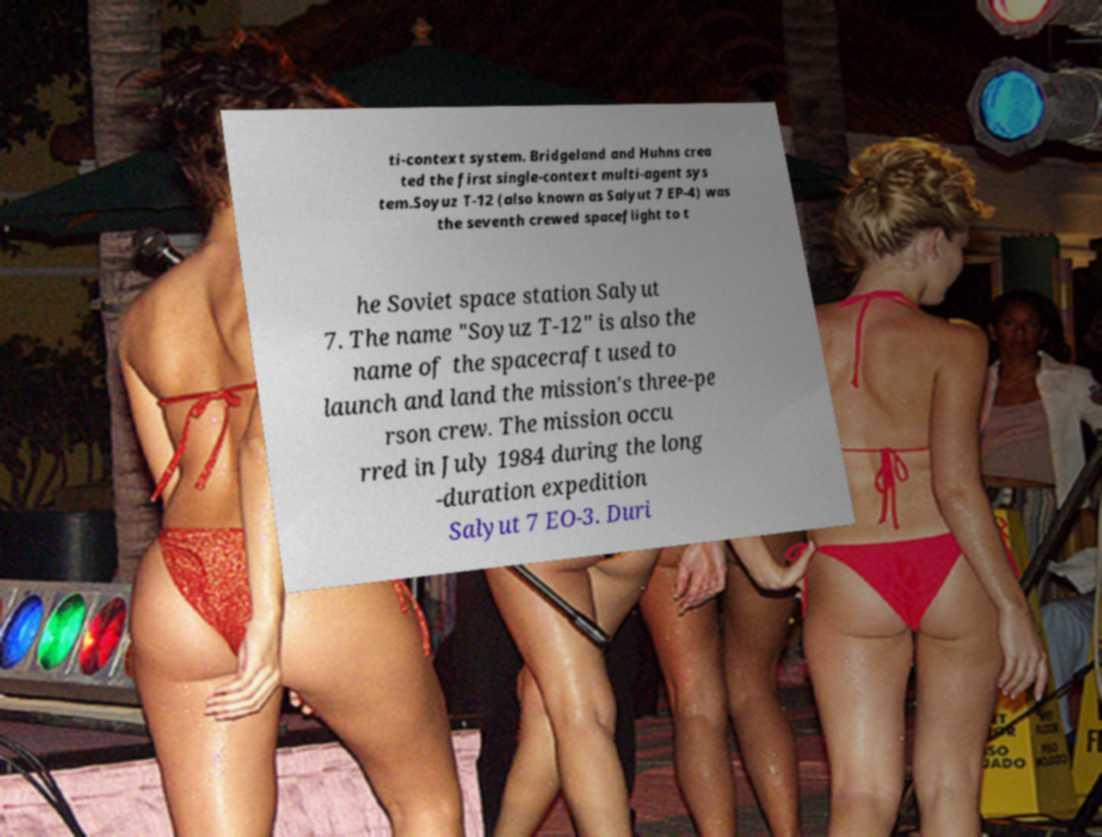Could you assist in decoding the text presented in this image and type it out clearly? ti-context system. Bridgeland and Huhns crea ted the first single-context multi-agent sys tem.Soyuz T-12 (also known as Salyut 7 EP-4) was the seventh crewed spaceflight to t he Soviet space station Salyut 7. The name "Soyuz T-12" is also the name of the spacecraft used to launch and land the mission's three-pe rson crew. The mission occu rred in July 1984 during the long -duration expedition Salyut 7 EO-3. Duri 